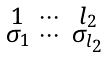Convert formula to latex. <formula><loc_0><loc_0><loc_500><loc_500>\begin{smallmatrix} 1 & \cdots & l _ { 2 } \\ \sigma _ { 1 } & \cdots & \sigma _ { l _ { 2 } } \end{smallmatrix}</formula> 